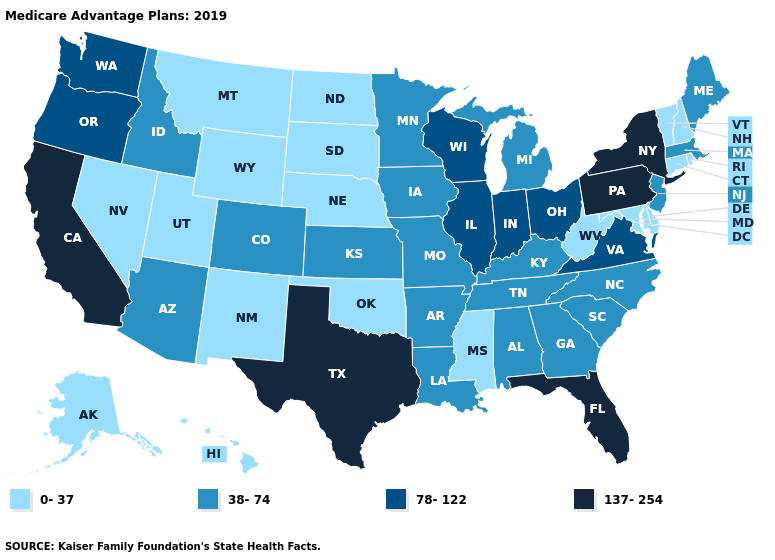Is the legend a continuous bar?
Answer briefly. No. Does Delaware have a lower value than New Mexico?
Keep it brief. No. Which states have the lowest value in the USA?
Keep it brief. Alaska, Connecticut, Delaware, Hawaii, Maryland, Mississippi, Montana, Nebraska, Nevada, New Hampshire, New Mexico, North Dakota, Oklahoma, Rhode Island, South Dakota, Utah, Vermont, West Virginia, Wyoming. Does the map have missing data?
Quick response, please. No. What is the value of Nebraska?
Be succinct. 0-37. Does the map have missing data?
Write a very short answer. No. Does California have the highest value in the USA?
Concise answer only. Yes. What is the value of Wyoming?
Short answer required. 0-37. What is the lowest value in the USA?
Be succinct. 0-37. Which states have the lowest value in the MidWest?
Give a very brief answer. Nebraska, North Dakota, South Dakota. Is the legend a continuous bar?
Give a very brief answer. No. What is the value of Alaska?
Concise answer only. 0-37. What is the value of Wisconsin?
Be succinct. 78-122. Name the states that have a value in the range 38-74?
Short answer required. Alabama, Arizona, Arkansas, Colorado, Georgia, Idaho, Iowa, Kansas, Kentucky, Louisiana, Maine, Massachusetts, Michigan, Minnesota, Missouri, New Jersey, North Carolina, South Carolina, Tennessee. What is the lowest value in the MidWest?
Keep it brief. 0-37. 